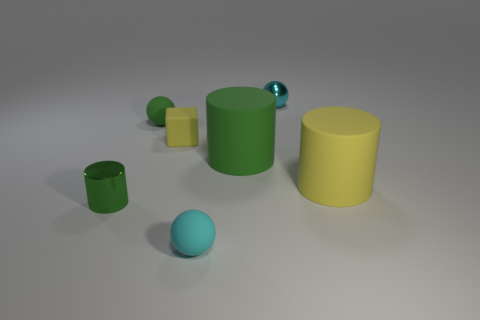What number of tiny matte things are there?
Offer a very short reply. 3. There is a green ball that is the same size as the block; what is it made of?
Your answer should be very brief. Rubber. Is there another cylinder of the same size as the yellow cylinder?
Your response must be concise. Yes. Do the metallic thing on the right side of the tiny cyan matte sphere and the big rubber object behind the yellow rubber cylinder have the same color?
Provide a short and direct response. No. What number of metal things are green spheres or tiny blue cylinders?
Your answer should be compact. 0. How many spheres are to the right of the small green thing that is behind the large matte cylinder in front of the big green thing?
Give a very brief answer. 2. What size is the cyan object that is the same material as the cube?
Make the answer very short. Small. How many matte objects are the same color as the small block?
Give a very brief answer. 1. Is the size of the green object that is right of the cyan rubber thing the same as the yellow matte cube?
Your answer should be compact. No. There is a small thing that is both left of the matte cube and behind the tiny green shiny cylinder; what is its color?
Your answer should be compact. Green. 